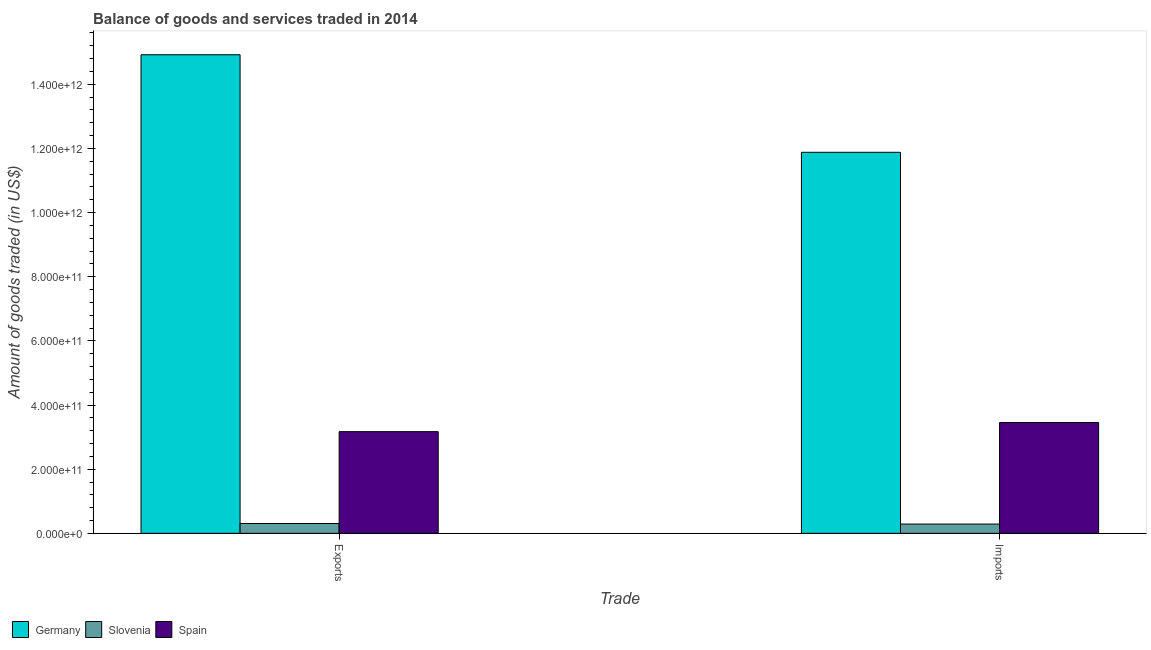How many bars are there on the 2nd tick from the left?
Offer a very short reply. 3. How many bars are there on the 1st tick from the right?
Offer a terse response. 3. What is the label of the 1st group of bars from the left?
Make the answer very short. Exports. What is the amount of goods exported in Germany?
Provide a short and direct response. 1.49e+12. Across all countries, what is the maximum amount of goods imported?
Your answer should be compact. 1.19e+12. Across all countries, what is the minimum amount of goods imported?
Keep it short and to the point. 2.90e+1. In which country was the amount of goods exported maximum?
Offer a very short reply. Germany. In which country was the amount of goods imported minimum?
Your answer should be compact. Slovenia. What is the total amount of goods imported in the graph?
Provide a short and direct response. 1.56e+12. What is the difference between the amount of goods imported in Spain and that in Slovenia?
Offer a terse response. 3.17e+11. What is the difference between the amount of goods exported in Germany and the amount of goods imported in Slovenia?
Offer a terse response. 1.46e+12. What is the average amount of goods exported per country?
Ensure brevity in your answer.  6.13e+11. What is the difference between the amount of goods exported and amount of goods imported in Slovenia?
Your answer should be very brief. 1.73e+09. In how many countries, is the amount of goods imported greater than 960000000000 US$?
Give a very brief answer. 1. What is the ratio of the amount of goods exported in Germany to that in Slovenia?
Offer a very short reply. 48.63. Is the amount of goods imported in Germany less than that in Slovenia?
Provide a succinct answer. No. What does the 2nd bar from the left in Exports represents?
Ensure brevity in your answer.  Slovenia. How many bars are there?
Ensure brevity in your answer.  6. How many countries are there in the graph?
Provide a short and direct response. 3. What is the difference between two consecutive major ticks on the Y-axis?
Offer a very short reply. 2.00e+11. Are the values on the major ticks of Y-axis written in scientific E-notation?
Your answer should be very brief. Yes. Does the graph contain any zero values?
Make the answer very short. No. Does the graph contain grids?
Your response must be concise. No. What is the title of the graph?
Your response must be concise. Balance of goods and services traded in 2014. Does "Afghanistan" appear as one of the legend labels in the graph?
Give a very brief answer. No. What is the label or title of the X-axis?
Your response must be concise. Trade. What is the label or title of the Y-axis?
Keep it short and to the point. Amount of goods traded (in US$). What is the Amount of goods traded (in US$) of Germany in Exports?
Provide a succinct answer. 1.49e+12. What is the Amount of goods traded (in US$) in Slovenia in Exports?
Make the answer very short. 3.07e+1. What is the Amount of goods traded (in US$) of Spain in Exports?
Offer a very short reply. 3.17e+11. What is the Amount of goods traded (in US$) of Germany in Imports?
Offer a terse response. 1.19e+12. What is the Amount of goods traded (in US$) of Slovenia in Imports?
Make the answer very short. 2.90e+1. What is the Amount of goods traded (in US$) of Spain in Imports?
Give a very brief answer. 3.46e+11. Across all Trade, what is the maximum Amount of goods traded (in US$) in Germany?
Your response must be concise. 1.49e+12. Across all Trade, what is the maximum Amount of goods traded (in US$) of Slovenia?
Offer a terse response. 3.07e+1. Across all Trade, what is the maximum Amount of goods traded (in US$) in Spain?
Make the answer very short. 3.46e+11. Across all Trade, what is the minimum Amount of goods traded (in US$) in Germany?
Your answer should be compact. 1.19e+12. Across all Trade, what is the minimum Amount of goods traded (in US$) in Slovenia?
Ensure brevity in your answer.  2.90e+1. Across all Trade, what is the minimum Amount of goods traded (in US$) of Spain?
Give a very brief answer. 3.17e+11. What is the total Amount of goods traded (in US$) of Germany in the graph?
Make the answer very short. 2.68e+12. What is the total Amount of goods traded (in US$) in Slovenia in the graph?
Offer a very short reply. 5.96e+1. What is the total Amount of goods traded (in US$) of Spain in the graph?
Provide a succinct answer. 6.63e+11. What is the difference between the Amount of goods traded (in US$) in Germany in Exports and that in Imports?
Offer a terse response. 3.04e+11. What is the difference between the Amount of goods traded (in US$) of Slovenia in Exports and that in Imports?
Your answer should be very brief. 1.73e+09. What is the difference between the Amount of goods traded (in US$) of Spain in Exports and that in Imports?
Make the answer very short. -2.85e+1. What is the difference between the Amount of goods traded (in US$) in Germany in Exports and the Amount of goods traded (in US$) in Slovenia in Imports?
Offer a terse response. 1.46e+12. What is the difference between the Amount of goods traded (in US$) of Germany in Exports and the Amount of goods traded (in US$) of Spain in Imports?
Offer a very short reply. 1.15e+12. What is the difference between the Amount of goods traded (in US$) of Slovenia in Exports and the Amount of goods traded (in US$) of Spain in Imports?
Offer a terse response. -3.15e+11. What is the average Amount of goods traded (in US$) of Germany per Trade?
Your answer should be compact. 1.34e+12. What is the average Amount of goods traded (in US$) in Slovenia per Trade?
Offer a terse response. 2.98e+1. What is the average Amount of goods traded (in US$) of Spain per Trade?
Your answer should be very brief. 3.31e+11. What is the difference between the Amount of goods traded (in US$) of Germany and Amount of goods traded (in US$) of Slovenia in Exports?
Give a very brief answer. 1.46e+12. What is the difference between the Amount of goods traded (in US$) in Germany and Amount of goods traded (in US$) in Spain in Exports?
Provide a short and direct response. 1.18e+12. What is the difference between the Amount of goods traded (in US$) of Slovenia and Amount of goods traded (in US$) of Spain in Exports?
Provide a succinct answer. -2.86e+11. What is the difference between the Amount of goods traded (in US$) in Germany and Amount of goods traded (in US$) in Slovenia in Imports?
Offer a terse response. 1.16e+12. What is the difference between the Amount of goods traded (in US$) of Germany and Amount of goods traded (in US$) of Spain in Imports?
Your answer should be very brief. 8.42e+11. What is the difference between the Amount of goods traded (in US$) of Slovenia and Amount of goods traded (in US$) of Spain in Imports?
Make the answer very short. -3.17e+11. What is the ratio of the Amount of goods traded (in US$) in Germany in Exports to that in Imports?
Ensure brevity in your answer.  1.26. What is the ratio of the Amount of goods traded (in US$) in Slovenia in Exports to that in Imports?
Provide a succinct answer. 1.06. What is the ratio of the Amount of goods traded (in US$) in Spain in Exports to that in Imports?
Your answer should be very brief. 0.92. What is the difference between the highest and the second highest Amount of goods traded (in US$) of Germany?
Provide a short and direct response. 3.04e+11. What is the difference between the highest and the second highest Amount of goods traded (in US$) of Slovenia?
Your answer should be very brief. 1.73e+09. What is the difference between the highest and the second highest Amount of goods traded (in US$) in Spain?
Give a very brief answer. 2.85e+1. What is the difference between the highest and the lowest Amount of goods traded (in US$) of Germany?
Your answer should be compact. 3.04e+11. What is the difference between the highest and the lowest Amount of goods traded (in US$) of Slovenia?
Provide a short and direct response. 1.73e+09. What is the difference between the highest and the lowest Amount of goods traded (in US$) of Spain?
Provide a succinct answer. 2.85e+1. 